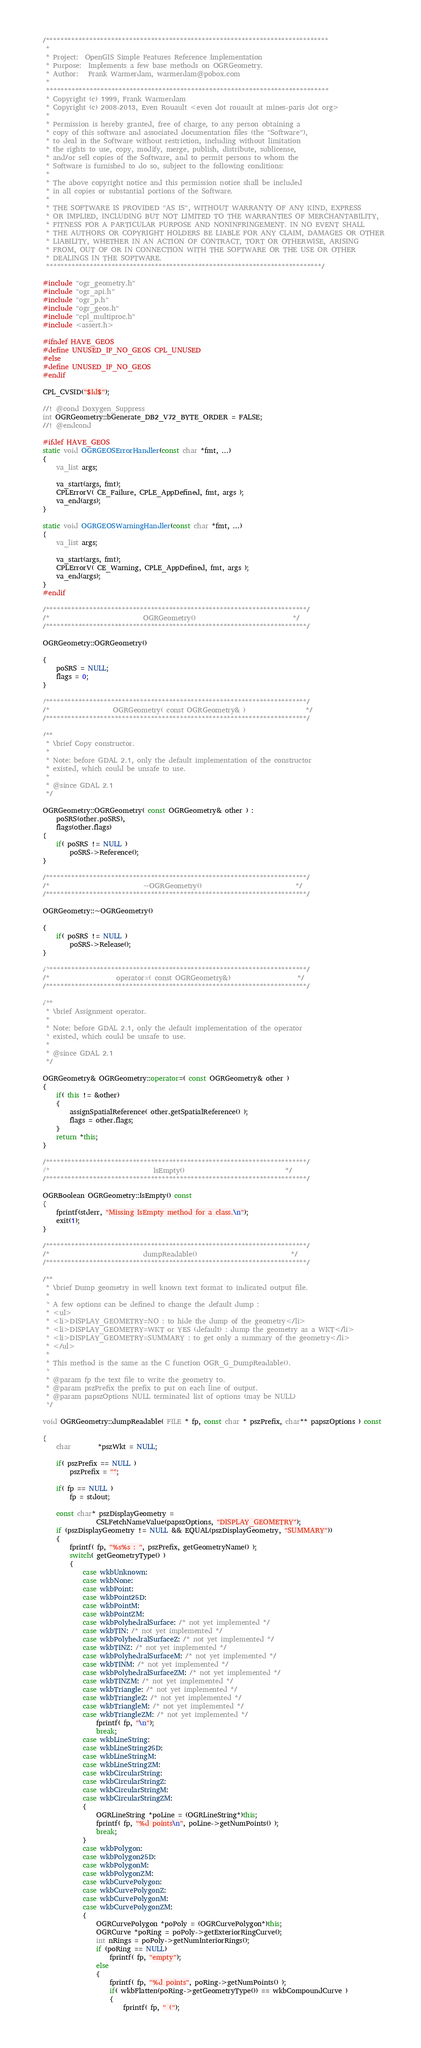Convert code to text. <code><loc_0><loc_0><loc_500><loc_500><_C++_>/******************************************************************************
 *
 * Project:  OpenGIS Simple Features Reference Implementation
 * Purpose:  Implements a few base methods on OGRGeometry.
 * Author:   Frank Warmerdam, warmerdam@pobox.com
 *
 ******************************************************************************
 * Copyright (c) 1999, Frank Warmerdam
 * Copyright (c) 2008-2013, Even Rouault <even dot rouault at mines-paris dot org>
 *
 * Permission is hereby granted, free of charge, to any person obtaining a
 * copy of this software and associated documentation files (the "Software"),
 * to deal in the Software without restriction, including without limitation
 * the rights to use, copy, modify, merge, publish, distribute, sublicense,
 * and/or sell copies of the Software, and to permit persons to whom the
 * Software is furnished to do so, subject to the following conditions:
 *
 * The above copyright notice and this permission notice shall be included
 * in all copies or substantial portions of the Software.
 *
 * THE SOFTWARE IS PROVIDED "AS IS", WITHOUT WARRANTY OF ANY KIND, EXPRESS
 * OR IMPLIED, INCLUDING BUT NOT LIMITED TO THE WARRANTIES OF MERCHANTABILITY,
 * FITNESS FOR A PARTICULAR PURPOSE AND NONINFRINGEMENT. IN NO EVENT SHALL
 * THE AUTHORS OR COPYRIGHT HOLDERS BE LIABLE FOR ANY CLAIM, DAMAGES OR OTHER
 * LIABILITY, WHETHER IN AN ACTION OF CONTRACT, TORT OR OTHERWISE, ARISING
 * FROM, OUT OF OR IN CONNECTION WITH THE SOFTWARE OR THE USE OR OTHER
 * DEALINGS IN THE SOFTWARE.
 ****************************************************************************/

#include "ogr_geometry.h"
#include "ogr_api.h"
#include "ogr_p.h"
#include "ogr_geos.h"
#include "cpl_multiproc.h"
#include <assert.h>

#ifndef HAVE_GEOS
#define UNUSED_IF_NO_GEOS CPL_UNUSED
#else
#define UNUSED_IF_NO_GEOS
#endif

CPL_CVSID("$Id$");

//! @cond Doxygen_Suppress
int OGRGeometry::bGenerate_DB2_V72_BYTE_ORDER = FALSE;
//! @endcond

#ifdef HAVE_GEOS
static void OGRGEOSErrorHandler(const char *fmt, ...)
{
    va_list args;

    va_start(args, fmt);
    CPLErrorV( CE_Failure, CPLE_AppDefined, fmt, args );
    va_end(args);
}

static void OGRGEOSWarningHandler(const char *fmt, ...)
{
    va_list args;

    va_start(args, fmt);
    CPLErrorV( CE_Warning, CPLE_AppDefined, fmt, args );
    va_end(args);
}
#endif

/************************************************************************/
/*                            OGRGeometry()                             */
/************************************************************************/

OGRGeometry::OGRGeometry()

{
    poSRS = NULL;
    flags = 0;
}

/************************************************************************/
/*                   OGRGeometry( const OGRGeometry& )                  */
/************************************************************************/

/**
 * \brief Copy constructor.
 *
 * Note: before GDAL 2.1, only the default implementation of the constructor
 * existed, which could be unsafe to use.
 *
 * @since GDAL 2.1
 */

OGRGeometry::OGRGeometry( const OGRGeometry& other ) :
    poSRS(other.poSRS),
    flags(other.flags)
{
    if( poSRS != NULL )
        poSRS->Reference();
}

/************************************************************************/
/*                            ~OGRGeometry()                            */
/************************************************************************/

OGRGeometry::~OGRGeometry()

{
    if( poSRS != NULL )
        poSRS->Release();
}

/************************************************************************/
/*                    operator=( const OGRGeometry&)                    */
/************************************************************************/

/**
 * \brief Assignment operator.
 *
 * Note: before GDAL 2.1, only the default implementation of the operator
 * existed, which could be unsafe to use.
 *
 * @since GDAL 2.1
 */

OGRGeometry& OGRGeometry::operator=( const OGRGeometry& other )
{
    if( this != &other)
    {
        assignSpatialReference( other.getSpatialReference() );
        flags = other.flags;
    }
    return *this;
}

/************************************************************************/
/*                               IsEmpty()                              */
/************************************************************************/

OGRBoolean OGRGeometry::IsEmpty() const
{
    fprintf(stderr, "Missing IsEmpty method for a class.\n");
    exit(1);
}

/************************************************************************/
/*                            dumpReadable()                            */
/************************************************************************/

/**
 * \brief Dump geometry in well known text format to indicated output file.
 *
 * A few options can be defined to change the default dump :
 * <ul>
 * <li>DISPLAY_GEOMETRY=NO : to hide the dump of the geometry</li>
 * <li>DISPLAY_GEOMETRY=WKT or YES (default) : dump the geometry as a WKT</li>
 * <li>DISPLAY_GEOMETRY=SUMMARY : to get only a summary of the geometry</li>
 * </ul>
 *
 * This method is the same as the C function OGR_G_DumpReadable().
 *
 * @param fp the text file to write the geometry to.
 * @param pszPrefix the prefix to put on each line of output.
 * @param papszOptions NULL terminated list of options (may be NULL)
 */

void OGRGeometry::dumpReadable( FILE * fp, const char * pszPrefix, char** papszOptions ) const

{
    char        *pszWkt = NULL;

    if( pszPrefix == NULL )
        pszPrefix = "";

    if( fp == NULL )
        fp = stdout;

    const char* pszDisplayGeometry =
                CSLFetchNameValue(papszOptions, "DISPLAY_GEOMETRY");
    if (pszDisplayGeometry != NULL && EQUAL(pszDisplayGeometry, "SUMMARY"))
    {
        fprintf( fp, "%s%s : ", pszPrefix, getGeometryName() );
        switch( getGeometryType() )
        {
            case wkbUnknown:
            case wkbNone:
            case wkbPoint:
            case wkbPoint25D:
            case wkbPointM:
            case wkbPointZM:
            case wkbPolyhedralSurface: /* not yet implemented */
            case wkbTIN: /* not yet implemented */
            case wkbPolyhedralSurfaceZ: /* not yet implemented */
            case wkbTINZ: /* not yet implemented */
            case wkbPolyhedralSurfaceM: /* not yet implemented */
            case wkbTINM: /* not yet implemented */
            case wkbPolyhedralSurfaceZM: /* not yet implemented */
            case wkbTINZM: /* not yet implemented */
            case wkbTriangle: /* not yet implemented */
            case wkbTriangleZ: /* not yet implemented */
            case wkbTriangleM: /* not yet implemented */
            case wkbTriangleZM: /* not yet implemented */
                fprintf( fp, "\n");
                break;
            case wkbLineString:
            case wkbLineString25D:
            case wkbLineStringM:
            case wkbLineStringZM:
            case wkbCircularString:
            case wkbCircularStringZ:
            case wkbCircularStringM:
            case wkbCircularStringZM:
            {
                OGRLineString *poLine = (OGRLineString*)this;
                fprintf( fp, "%d points\n", poLine->getNumPoints() );
                break;
            }
            case wkbPolygon:
            case wkbPolygon25D:
            case wkbPolygonM:
            case wkbPolygonZM:
            case wkbCurvePolygon:
            case wkbCurvePolygonZ:
            case wkbCurvePolygonM:
            case wkbCurvePolygonZM:
            {
                OGRCurvePolygon *poPoly = (OGRCurvePolygon*)this;
                OGRCurve *poRing = poPoly->getExteriorRingCurve();
                int nRings = poPoly->getNumInteriorRings();
                if (poRing == NULL)
                    fprintf( fp, "empty");
                else
                {
                    fprintf( fp, "%d points", poRing->getNumPoints() );
                    if( wkbFlatten(poRing->getGeometryType()) == wkbCompoundCurve )
                    {
                        fprintf( fp, " (");</code> 